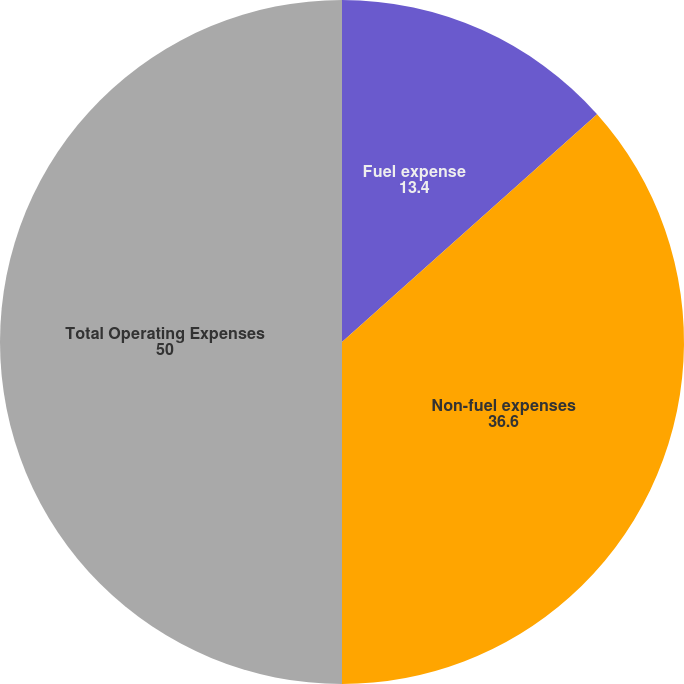<chart> <loc_0><loc_0><loc_500><loc_500><pie_chart><fcel>Fuel expense<fcel>Non-fuel expenses<fcel>Total Operating Expenses<nl><fcel>13.4%<fcel>36.6%<fcel>50.0%<nl></chart> 